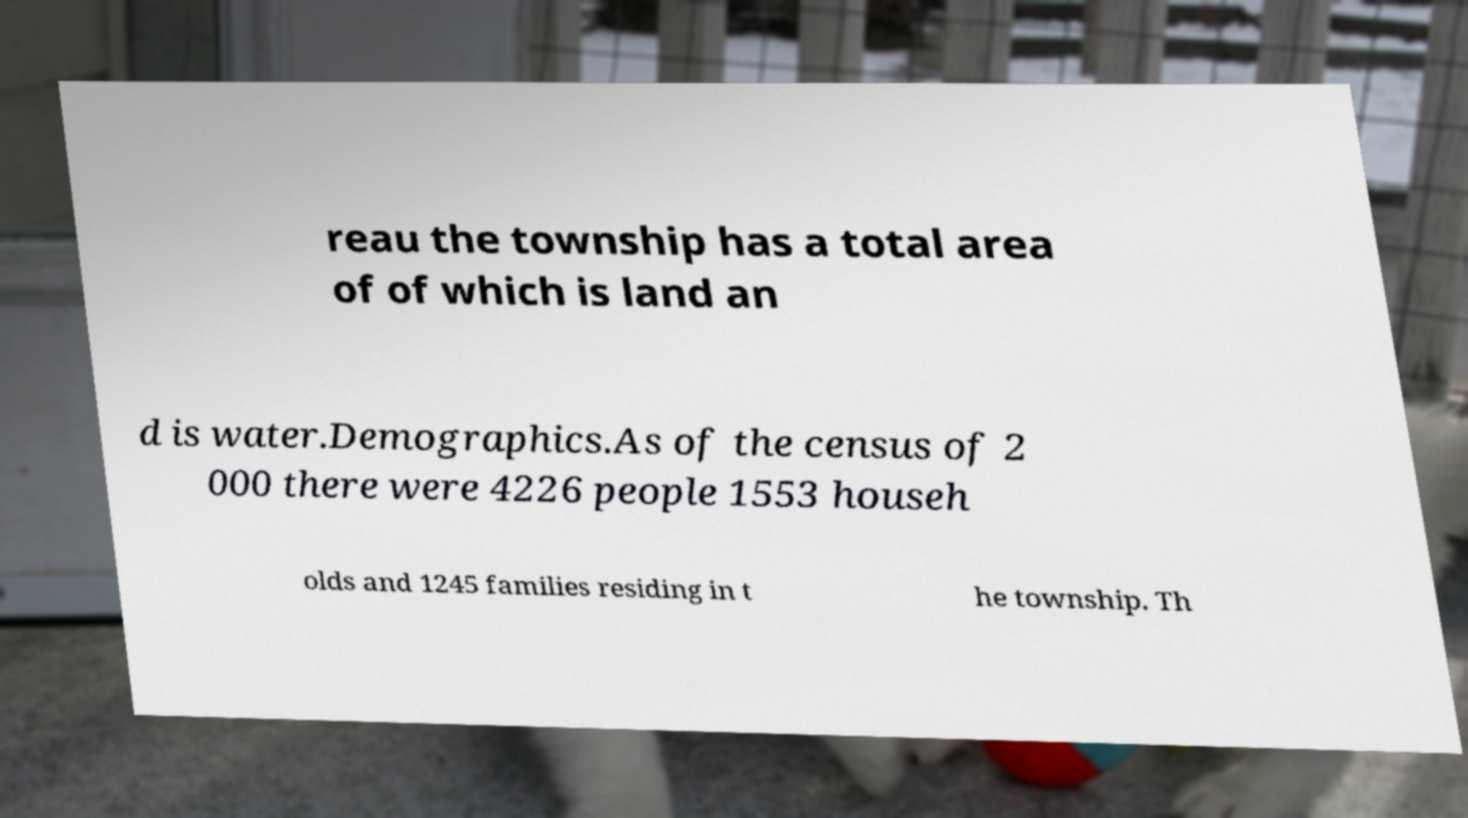Please identify and transcribe the text found in this image. reau the township has a total area of of which is land an d is water.Demographics.As of the census of 2 000 there were 4226 people 1553 househ olds and 1245 families residing in t he township. Th 